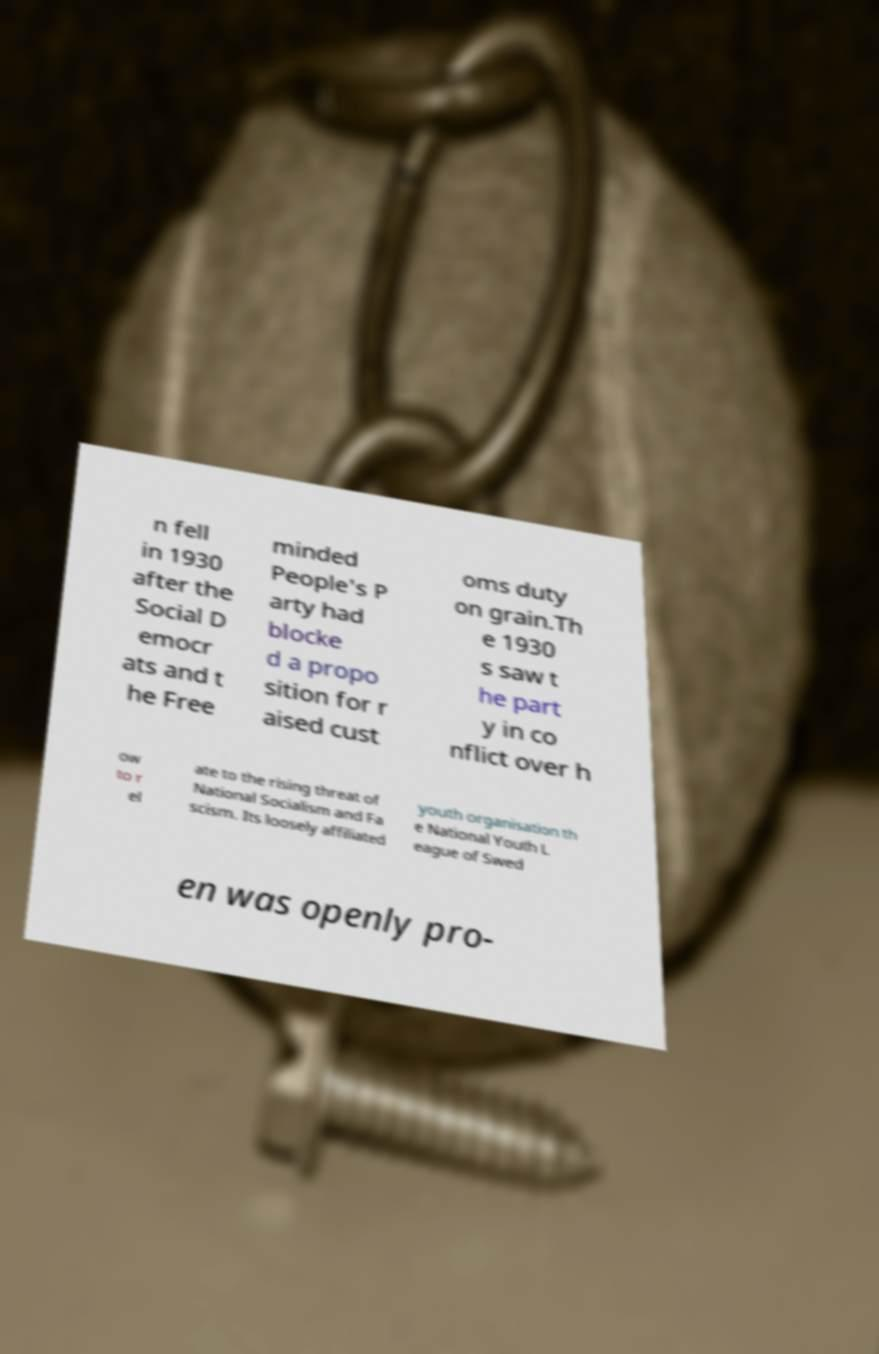I need the written content from this picture converted into text. Can you do that? n fell in 1930 after the Social D emocr ats and t he Free minded People's P arty had blocke d a propo sition for r aised cust oms duty on grain.Th e 1930 s saw t he part y in co nflict over h ow to r el ate to the rising threat of National Socialism and Fa scism. Its loosely affiliated youth organisation th e National Youth L eague of Swed en was openly pro- 